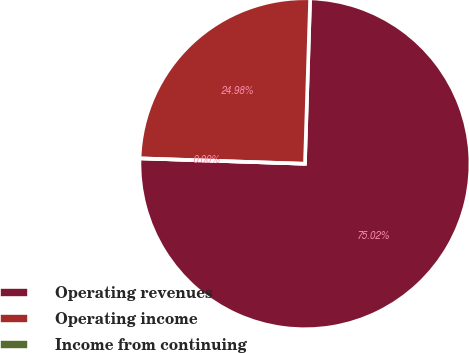Convert chart. <chart><loc_0><loc_0><loc_500><loc_500><pie_chart><fcel>Operating revenues<fcel>Operating income<fcel>Income from continuing<nl><fcel>75.02%<fcel>24.98%<fcel>0.0%<nl></chart> 